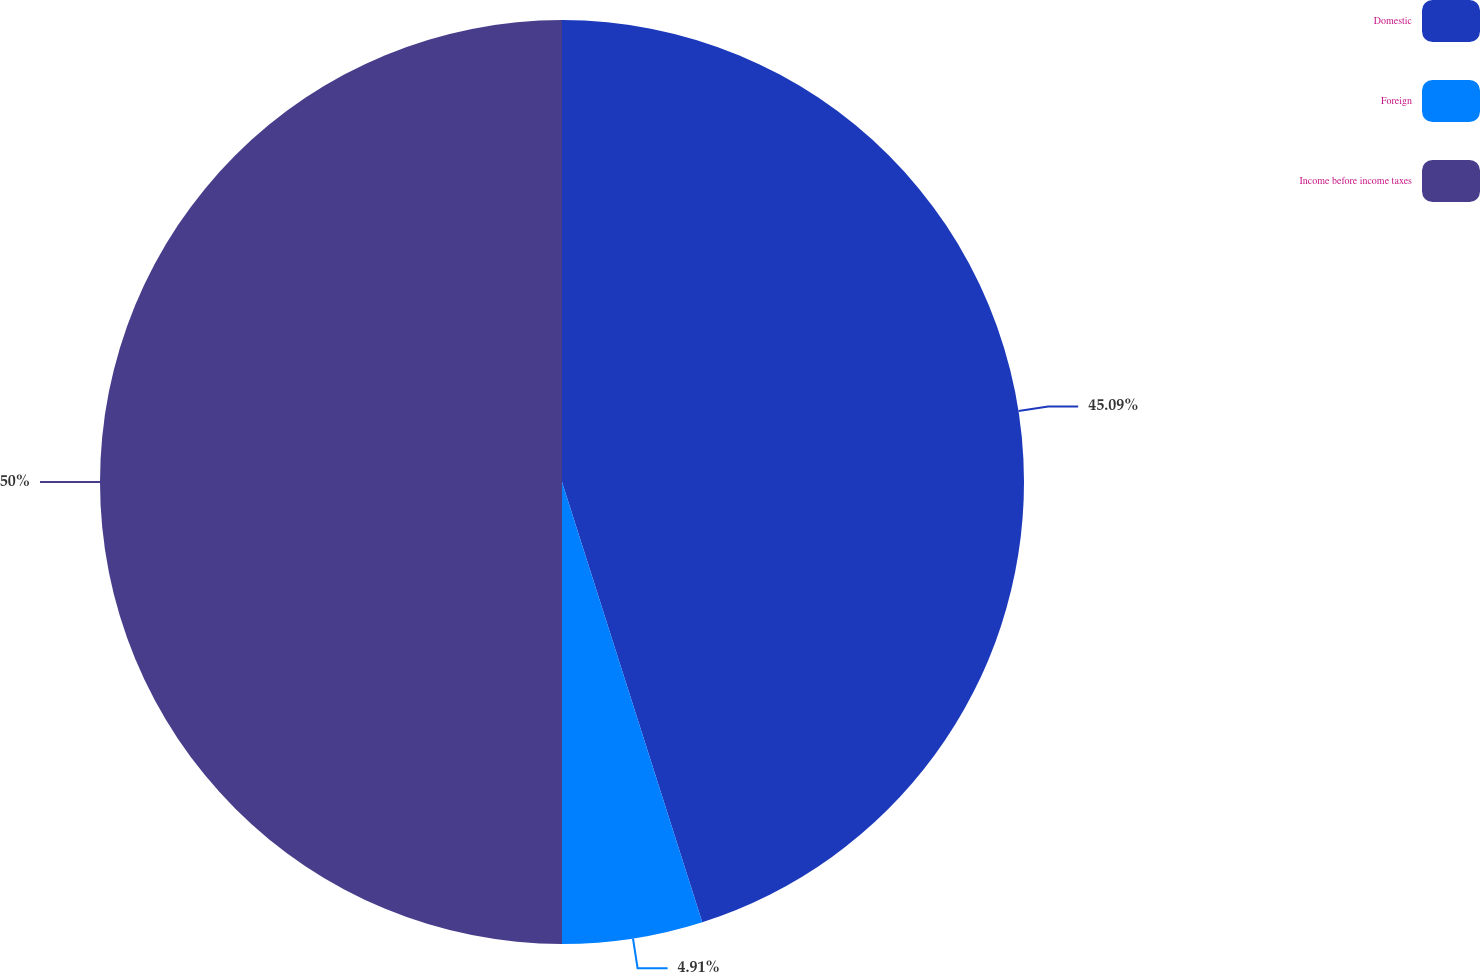Convert chart to OTSL. <chart><loc_0><loc_0><loc_500><loc_500><pie_chart><fcel>Domestic<fcel>Foreign<fcel>Income before income taxes<nl><fcel>45.09%<fcel>4.91%<fcel>50.0%<nl></chart> 